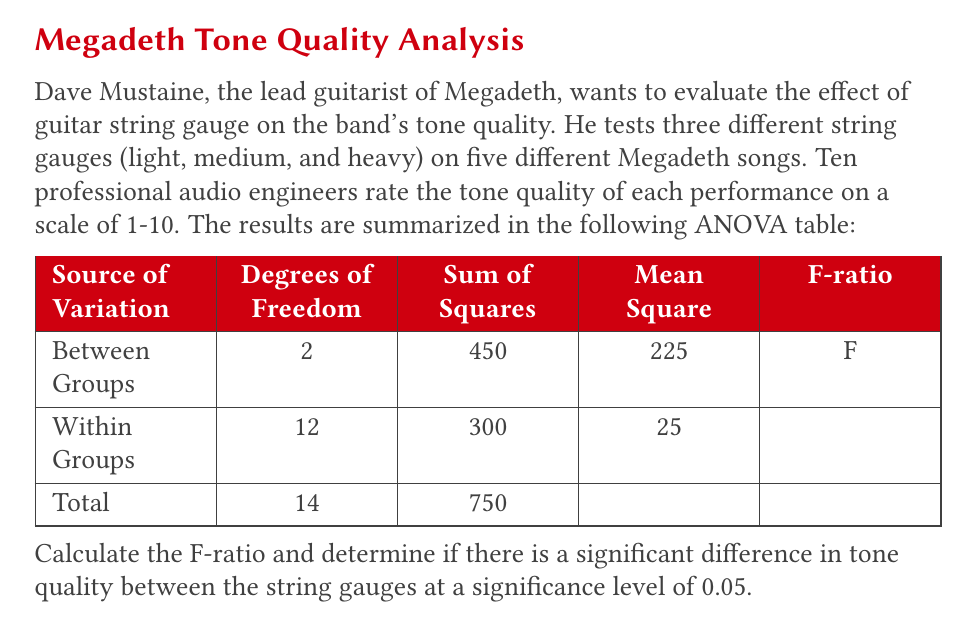Provide a solution to this math problem. To solve this problem, we'll follow these steps:

1. Calculate the F-ratio:
   The F-ratio is the ratio of the Mean Square Between Groups to the Mean Square Within Groups.
   
   $$F = \frac{MS_{Between}}{MS_{Within}} = \frac{225}{25} = 9$$

2. Determine the critical F-value:
   To find the critical F-value, we need:
   - Degrees of freedom for the numerator (Between Groups): 2
   - Degrees of freedom for the denominator (Within Groups): 12
   - Significance level: 0.05
   
   Using an F-distribution table or calculator, we find:
   $$F_{critical} (2, 12, 0.05) \approx 3.89$$

3. Compare the calculated F-ratio to the critical F-value:
   If the calculated F-ratio is greater than the critical F-value, we reject the null hypothesis and conclude that there is a significant difference between the groups.

   $$9 > 3.89$$

4. Interpret the results:
   Since the calculated F-ratio (9) is greater than the critical F-value (3.89), we reject the null hypothesis. This means there is a statistically significant difference in tone quality between the different string gauges at the 0.05 significance level.

As a die-hard Megadeth fan, you can appreciate that this analysis shows that the choice of string gauge significantly affects the tone quality of Megadeth's music, as perceived by professional audio engineers.
Answer: The F-ratio is 9. Since 9 > 3.89 (the critical F-value), we conclude that there is a statistically significant difference in tone quality between the different string gauges at the 0.05 significance level. 